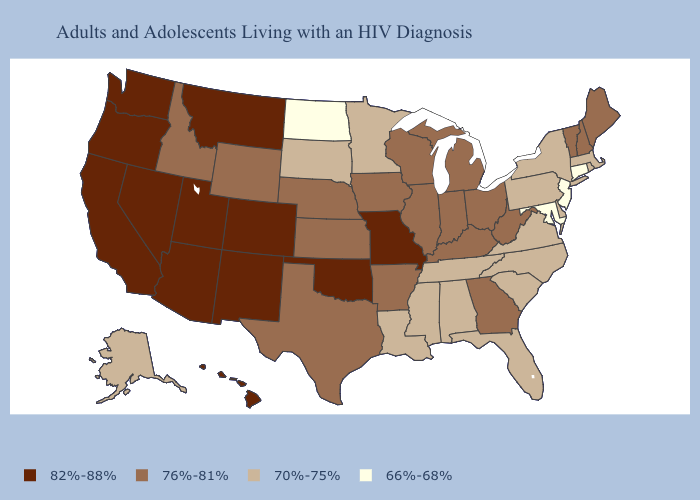Among the states that border North Carolina , does Georgia have the lowest value?
Short answer required. No. Does Connecticut have the lowest value in the USA?
Keep it brief. Yes. Which states have the lowest value in the South?
Short answer required. Maryland. Name the states that have a value in the range 70%-75%?
Concise answer only. Alabama, Alaska, Delaware, Florida, Louisiana, Massachusetts, Minnesota, Mississippi, New York, North Carolina, Pennsylvania, Rhode Island, South Carolina, South Dakota, Tennessee, Virginia. Which states have the highest value in the USA?
Write a very short answer. Arizona, California, Colorado, Hawaii, Missouri, Montana, Nevada, New Mexico, Oklahoma, Oregon, Utah, Washington. What is the lowest value in the West?
Be succinct. 70%-75%. Name the states that have a value in the range 76%-81%?
Keep it brief. Arkansas, Georgia, Idaho, Illinois, Indiana, Iowa, Kansas, Kentucky, Maine, Michigan, Nebraska, New Hampshire, Ohio, Texas, Vermont, West Virginia, Wisconsin, Wyoming. Name the states that have a value in the range 76%-81%?
Be succinct. Arkansas, Georgia, Idaho, Illinois, Indiana, Iowa, Kansas, Kentucky, Maine, Michigan, Nebraska, New Hampshire, Ohio, Texas, Vermont, West Virginia, Wisconsin, Wyoming. Which states have the lowest value in the USA?
Short answer required. Connecticut, Maryland, New Jersey, North Dakota. What is the lowest value in the South?
Concise answer only. 66%-68%. What is the value of Mississippi?
Short answer required. 70%-75%. What is the lowest value in the USA?
Quick response, please. 66%-68%. How many symbols are there in the legend?
Be succinct. 4. Name the states that have a value in the range 82%-88%?
Concise answer only. Arizona, California, Colorado, Hawaii, Missouri, Montana, Nevada, New Mexico, Oklahoma, Oregon, Utah, Washington. 